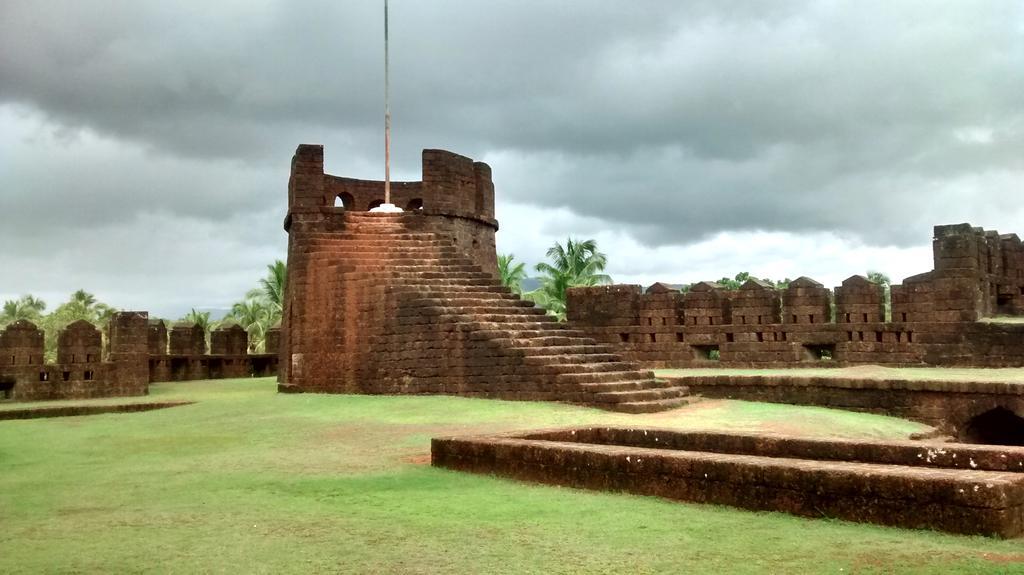Describe this image in one or two sentences. In this image we can see walls, steps, pole, trees, grass and cloudy sky. 